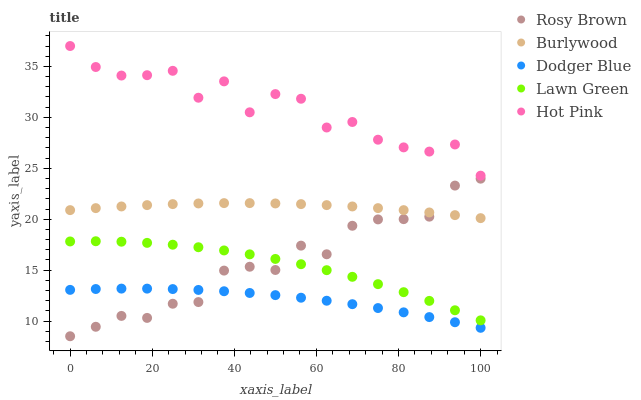Does Dodger Blue have the minimum area under the curve?
Answer yes or no. Yes. Does Hot Pink have the maximum area under the curve?
Answer yes or no. Yes. Does Lawn Green have the minimum area under the curve?
Answer yes or no. No. Does Lawn Green have the maximum area under the curve?
Answer yes or no. No. Is Burlywood the smoothest?
Answer yes or no. Yes. Is Hot Pink the roughest?
Answer yes or no. Yes. Is Lawn Green the smoothest?
Answer yes or no. No. Is Lawn Green the roughest?
Answer yes or no. No. Does Rosy Brown have the lowest value?
Answer yes or no. Yes. Does Lawn Green have the lowest value?
Answer yes or no. No. Does Hot Pink have the highest value?
Answer yes or no. Yes. Does Lawn Green have the highest value?
Answer yes or no. No. Is Rosy Brown less than Hot Pink?
Answer yes or no. Yes. Is Hot Pink greater than Lawn Green?
Answer yes or no. Yes. Does Rosy Brown intersect Lawn Green?
Answer yes or no. Yes. Is Rosy Brown less than Lawn Green?
Answer yes or no. No. Is Rosy Brown greater than Lawn Green?
Answer yes or no. No. Does Rosy Brown intersect Hot Pink?
Answer yes or no. No. 